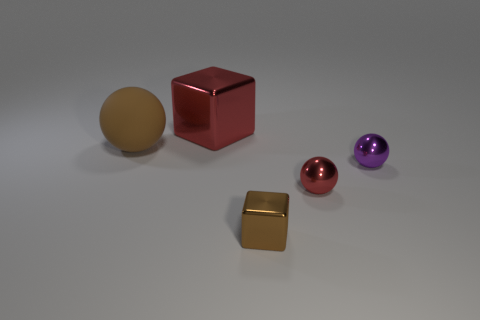Add 5 big brown rubber blocks. How many objects exist? 10 Subtract all tiny balls. How many balls are left? 1 Subtract all brown spheres. How many spheres are left? 2 Subtract 2 cubes. How many cubes are left? 0 Subtract all spheres. How many objects are left? 2 Subtract all purple balls. Subtract all purple cubes. How many balls are left? 2 Subtract all green cylinders. How many brown cubes are left? 1 Subtract all purple balls. Subtract all small blue spheres. How many objects are left? 4 Add 3 small purple balls. How many small purple balls are left? 4 Add 5 brown rubber spheres. How many brown rubber spheres exist? 6 